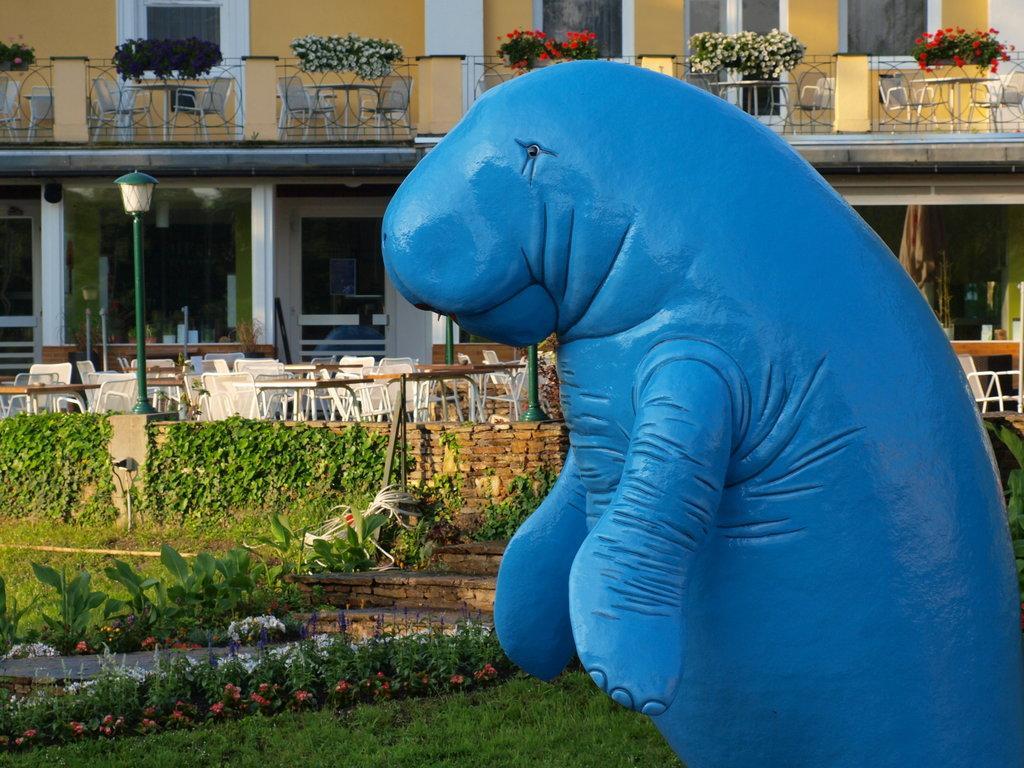In one or two sentences, can you explain what this image depicts? In this image there is the grass towards the bottom of the image, there are plants, there is a pole, there is a light, there is an object towards the right of the image that looks like an animal, there are cars, there are tables, there is wall towards the top of the image, there are doors, there are windows, there are windows. 